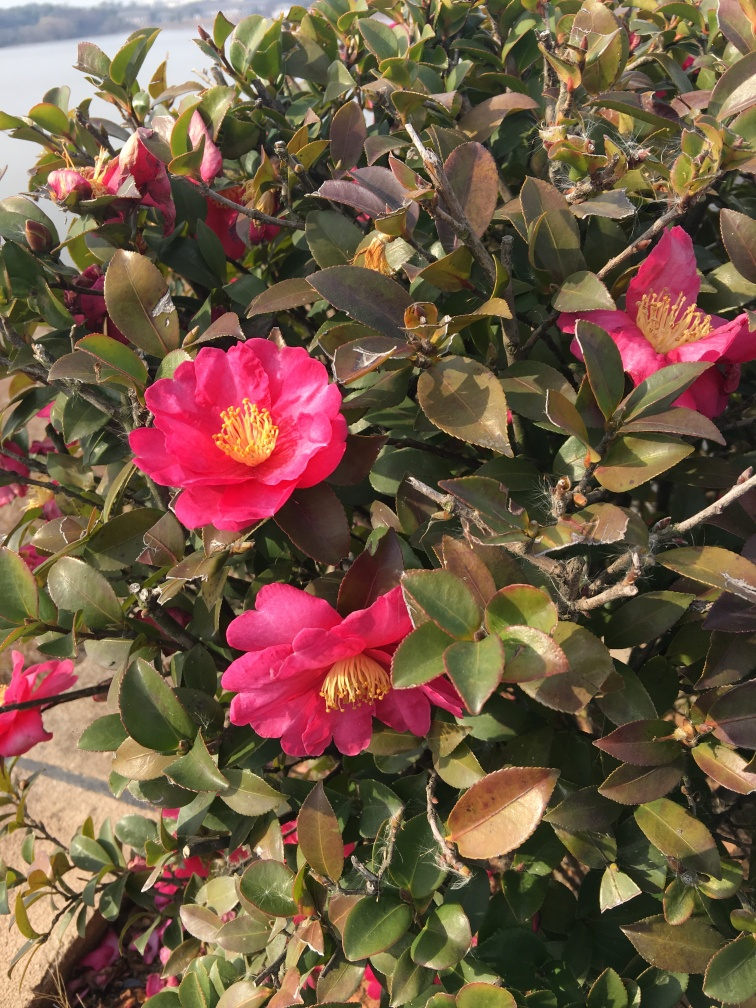What could the presence of these flowers tell us about the local climate? The presence of camellia flowers suggests a mild climate, as these plants prefer conditions that are not too extreme, with moderate rainfall and temperatures that do not usually dip below freezing. They are an excellent indicator of a temperate regional climate where they are often cultivated as ornamental flowers. 